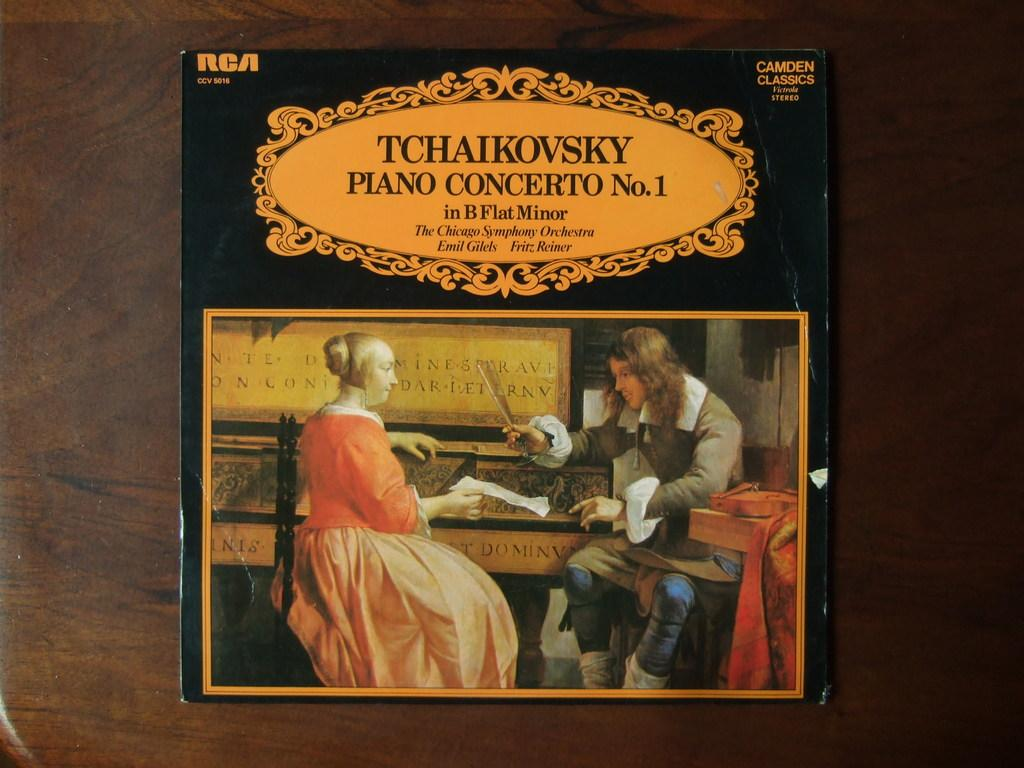<image>
Summarize the visual content of the image. a concerto that was made by Tchaikovsky in B Flat Minor 